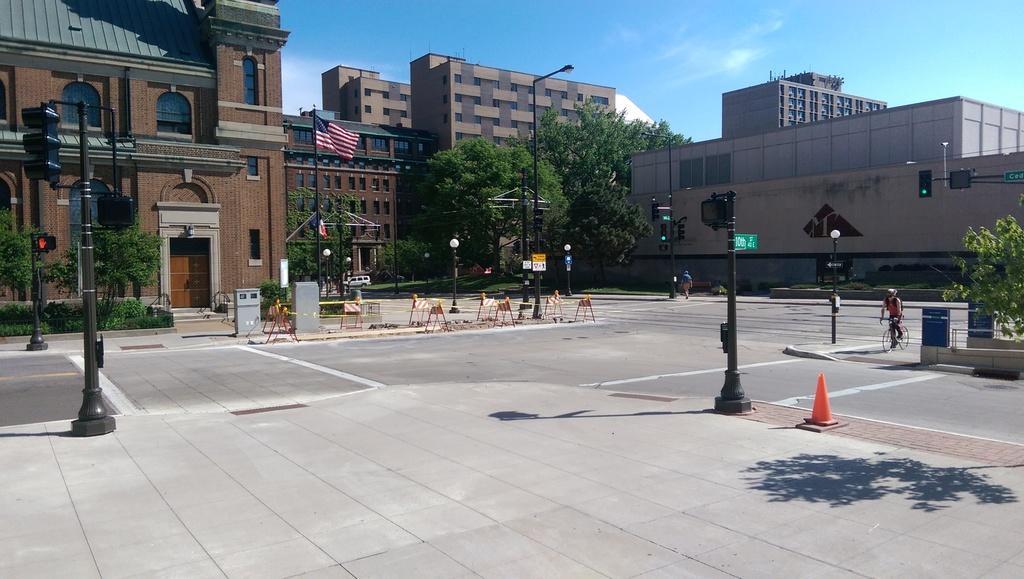In one or two sentences, can you explain what this image depicts? In this image we can see a group of buildings. We can also see a car, a person standing, some stands on the road, the traffic signals, a group of trees, the flag and some containers. On the right side we can see a person riding bicycle and a street pole. We can also see the sky which looks cloudy. 